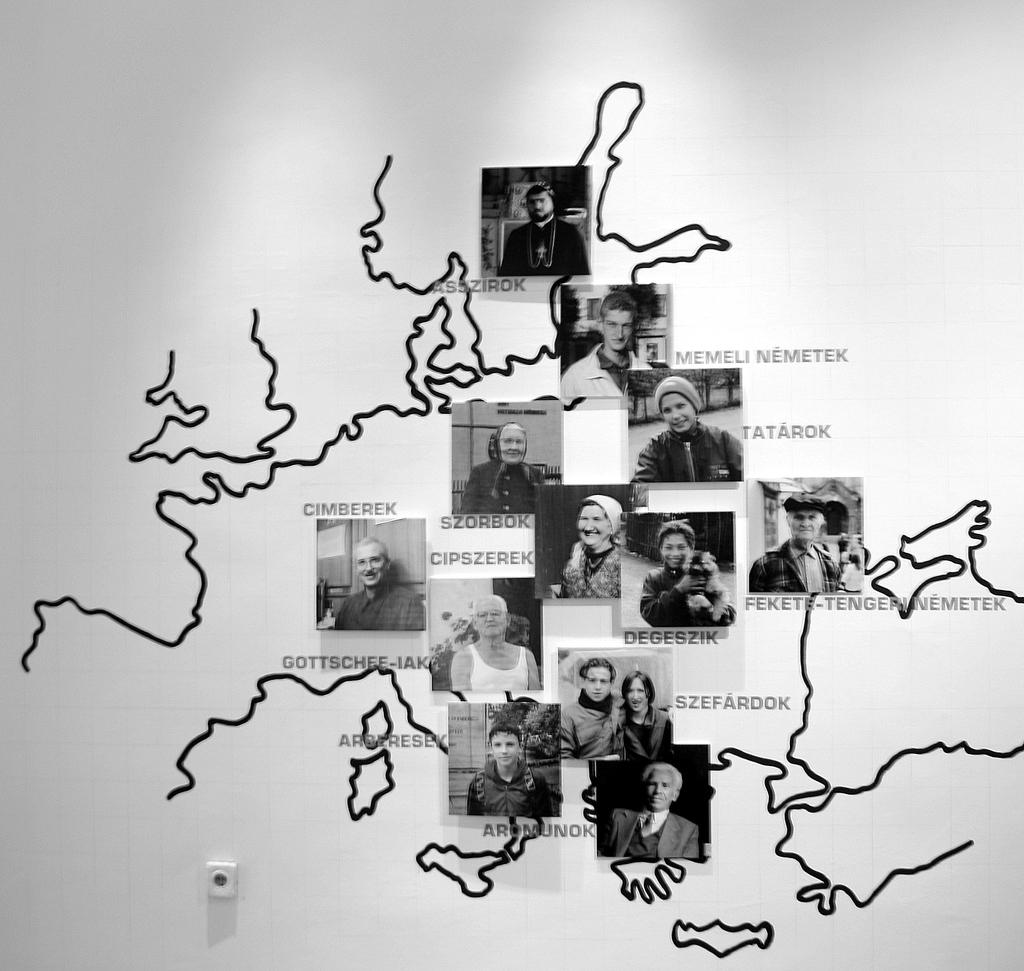What is the main object in the image? There is a board in the image. What is placed on the board? There are photos, text, and curved lines on the board. Can you describe the nature of the lines on the board? The lines on the board are curved. Where is the lettuce placed on the board in the image? There is no lettuce present on the board in the image. What type of bear can be seen interacting with the board in the image? There is no bear present in the image. 